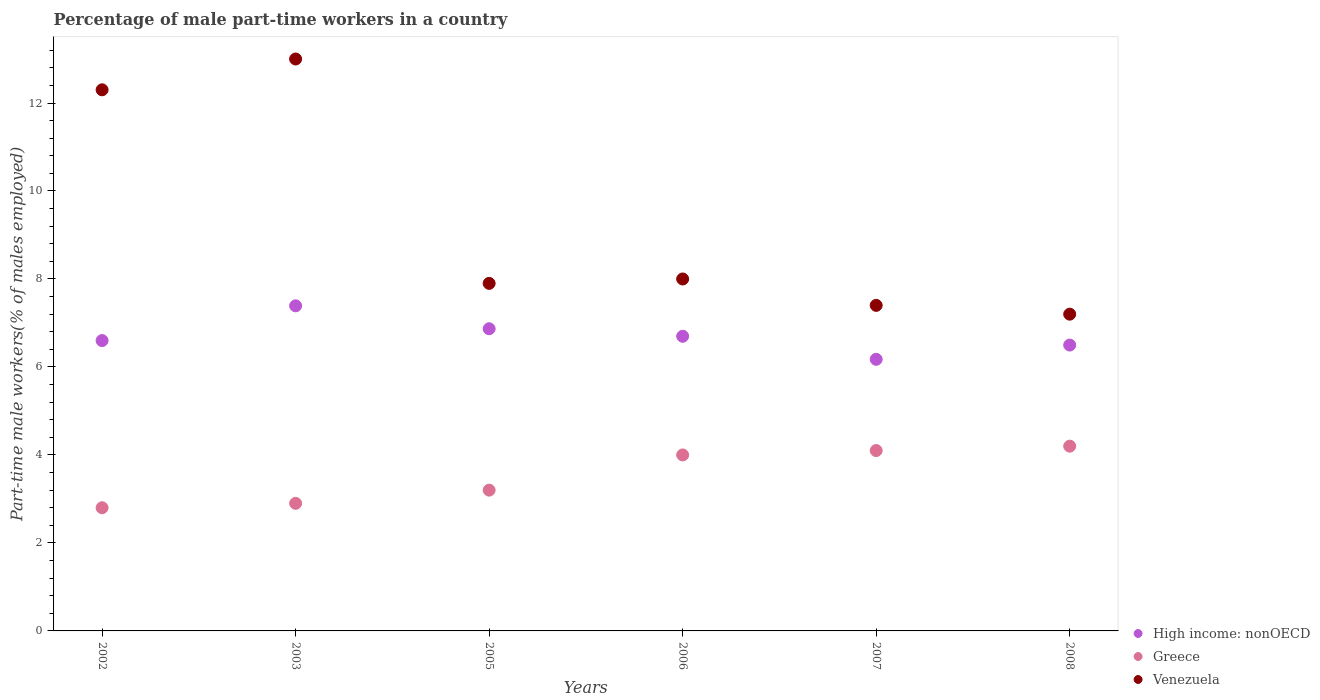How many different coloured dotlines are there?
Offer a very short reply. 3. Is the number of dotlines equal to the number of legend labels?
Provide a succinct answer. Yes. What is the percentage of male part-time workers in High income: nonOECD in 2006?
Offer a terse response. 6.7. Across all years, what is the minimum percentage of male part-time workers in Venezuela?
Offer a terse response. 7.2. In which year was the percentage of male part-time workers in Greece maximum?
Offer a very short reply. 2008. In which year was the percentage of male part-time workers in Venezuela minimum?
Give a very brief answer. 2008. What is the total percentage of male part-time workers in High income: nonOECD in the graph?
Your response must be concise. 40.23. What is the difference between the percentage of male part-time workers in Greece in 2003 and that in 2007?
Your answer should be compact. -1.2. What is the difference between the percentage of male part-time workers in Venezuela in 2002 and the percentage of male part-time workers in High income: nonOECD in 2003?
Provide a succinct answer. 4.91. What is the average percentage of male part-time workers in Venezuela per year?
Ensure brevity in your answer.  9.3. In the year 2002, what is the difference between the percentage of male part-time workers in Greece and percentage of male part-time workers in High income: nonOECD?
Keep it short and to the point. -3.8. In how many years, is the percentage of male part-time workers in High income: nonOECD greater than 4.8 %?
Offer a very short reply. 6. What is the ratio of the percentage of male part-time workers in High income: nonOECD in 2002 to that in 2008?
Provide a short and direct response. 1.02. Is the percentage of male part-time workers in High income: nonOECD in 2003 less than that in 2005?
Offer a terse response. No. What is the difference between the highest and the second highest percentage of male part-time workers in Greece?
Offer a terse response. 0.1. What is the difference between the highest and the lowest percentage of male part-time workers in High income: nonOECD?
Provide a succinct answer. 1.22. In how many years, is the percentage of male part-time workers in High income: nonOECD greater than the average percentage of male part-time workers in High income: nonOECD taken over all years?
Provide a short and direct response. 2. Is it the case that in every year, the sum of the percentage of male part-time workers in Greece and percentage of male part-time workers in High income: nonOECD  is greater than the percentage of male part-time workers in Venezuela?
Offer a terse response. No. Is the percentage of male part-time workers in High income: nonOECD strictly greater than the percentage of male part-time workers in Greece over the years?
Your answer should be very brief. Yes. Is the percentage of male part-time workers in High income: nonOECD strictly less than the percentage of male part-time workers in Greece over the years?
Provide a succinct answer. No. How many dotlines are there?
Ensure brevity in your answer.  3. How many years are there in the graph?
Your answer should be very brief. 6. Are the values on the major ticks of Y-axis written in scientific E-notation?
Provide a short and direct response. No. How many legend labels are there?
Keep it short and to the point. 3. What is the title of the graph?
Your answer should be very brief. Percentage of male part-time workers in a country. What is the label or title of the X-axis?
Offer a very short reply. Years. What is the label or title of the Y-axis?
Offer a terse response. Part-time male workers(% of males employed). What is the Part-time male workers(% of males employed) of High income: nonOECD in 2002?
Offer a terse response. 6.6. What is the Part-time male workers(% of males employed) in Greece in 2002?
Keep it short and to the point. 2.8. What is the Part-time male workers(% of males employed) in Venezuela in 2002?
Your response must be concise. 12.3. What is the Part-time male workers(% of males employed) in High income: nonOECD in 2003?
Your response must be concise. 7.39. What is the Part-time male workers(% of males employed) in Greece in 2003?
Give a very brief answer. 2.9. What is the Part-time male workers(% of males employed) in High income: nonOECD in 2005?
Your answer should be very brief. 6.87. What is the Part-time male workers(% of males employed) in Greece in 2005?
Give a very brief answer. 3.2. What is the Part-time male workers(% of males employed) in Venezuela in 2005?
Make the answer very short. 7.9. What is the Part-time male workers(% of males employed) of High income: nonOECD in 2006?
Your answer should be compact. 6.7. What is the Part-time male workers(% of males employed) in Venezuela in 2006?
Your answer should be compact. 8. What is the Part-time male workers(% of males employed) of High income: nonOECD in 2007?
Offer a terse response. 6.17. What is the Part-time male workers(% of males employed) of Greece in 2007?
Your answer should be very brief. 4.1. What is the Part-time male workers(% of males employed) of Venezuela in 2007?
Your answer should be compact. 7.4. What is the Part-time male workers(% of males employed) of High income: nonOECD in 2008?
Your answer should be very brief. 6.5. What is the Part-time male workers(% of males employed) in Greece in 2008?
Keep it short and to the point. 4.2. What is the Part-time male workers(% of males employed) of Venezuela in 2008?
Make the answer very short. 7.2. Across all years, what is the maximum Part-time male workers(% of males employed) in High income: nonOECD?
Your answer should be compact. 7.39. Across all years, what is the maximum Part-time male workers(% of males employed) in Greece?
Provide a succinct answer. 4.2. Across all years, what is the maximum Part-time male workers(% of males employed) in Venezuela?
Keep it short and to the point. 13. Across all years, what is the minimum Part-time male workers(% of males employed) of High income: nonOECD?
Keep it short and to the point. 6.17. Across all years, what is the minimum Part-time male workers(% of males employed) of Greece?
Make the answer very short. 2.8. Across all years, what is the minimum Part-time male workers(% of males employed) of Venezuela?
Your answer should be compact. 7.2. What is the total Part-time male workers(% of males employed) in High income: nonOECD in the graph?
Provide a succinct answer. 40.23. What is the total Part-time male workers(% of males employed) in Greece in the graph?
Offer a terse response. 21.2. What is the total Part-time male workers(% of males employed) in Venezuela in the graph?
Ensure brevity in your answer.  55.8. What is the difference between the Part-time male workers(% of males employed) of High income: nonOECD in 2002 and that in 2003?
Provide a succinct answer. -0.79. What is the difference between the Part-time male workers(% of males employed) of Venezuela in 2002 and that in 2003?
Make the answer very short. -0.7. What is the difference between the Part-time male workers(% of males employed) of High income: nonOECD in 2002 and that in 2005?
Ensure brevity in your answer.  -0.27. What is the difference between the Part-time male workers(% of males employed) of Greece in 2002 and that in 2005?
Provide a succinct answer. -0.4. What is the difference between the Part-time male workers(% of males employed) of Venezuela in 2002 and that in 2005?
Give a very brief answer. 4.4. What is the difference between the Part-time male workers(% of males employed) in High income: nonOECD in 2002 and that in 2006?
Your response must be concise. -0.1. What is the difference between the Part-time male workers(% of males employed) of Venezuela in 2002 and that in 2006?
Your response must be concise. 4.3. What is the difference between the Part-time male workers(% of males employed) of High income: nonOECD in 2002 and that in 2007?
Ensure brevity in your answer.  0.43. What is the difference between the Part-time male workers(% of males employed) in Greece in 2002 and that in 2007?
Provide a succinct answer. -1.3. What is the difference between the Part-time male workers(% of males employed) in Venezuela in 2002 and that in 2007?
Your answer should be compact. 4.9. What is the difference between the Part-time male workers(% of males employed) in High income: nonOECD in 2002 and that in 2008?
Make the answer very short. 0.1. What is the difference between the Part-time male workers(% of males employed) of Greece in 2002 and that in 2008?
Give a very brief answer. -1.4. What is the difference between the Part-time male workers(% of males employed) in High income: nonOECD in 2003 and that in 2005?
Ensure brevity in your answer.  0.52. What is the difference between the Part-time male workers(% of males employed) in Venezuela in 2003 and that in 2005?
Your answer should be compact. 5.1. What is the difference between the Part-time male workers(% of males employed) in High income: nonOECD in 2003 and that in 2006?
Your answer should be very brief. 0.69. What is the difference between the Part-time male workers(% of males employed) in Greece in 2003 and that in 2006?
Give a very brief answer. -1.1. What is the difference between the Part-time male workers(% of males employed) in Venezuela in 2003 and that in 2006?
Your answer should be compact. 5. What is the difference between the Part-time male workers(% of males employed) of High income: nonOECD in 2003 and that in 2007?
Your answer should be compact. 1.22. What is the difference between the Part-time male workers(% of males employed) of High income: nonOECD in 2003 and that in 2008?
Your answer should be very brief. 0.89. What is the difference between the Part-time male workers(% of males employed) in Greece in 2003 and that in 2008?
Provide a succinct answer. -1.3. What is the difference between the Part-time male workers(% of males employed) of Venezuela in 2003 and that in 2008?
Provide a short and direct response. 5.8. What is the difference between the Part-time male workers(% of males employed) of High income: nonOECD in 2005 and that in 2006?
Provide a succinct answer. 0.17. What is the difference between the Part-time male workers(% of males employed) in High income: nonOECD in 2005 and that in 2007?
Offer a terse response. 0.7. What is the difference between the Part-time male workers(% of males employed) in Greece in 2005 and that in 2007?
Keep it short and to the point. -0.9. What is the difference between the Part-time male workers(% of males employed) of Venezuela in 2005 and that in 2007?
Make the answer very short. 0.5. What is the difference between the Part-time male workers(% of males employed) of High income: nonOECD in 2005 and that in 2008?
Keep it short and to the point. 0.37. What is the difference between the Part-time male workers(% of males employed) in Greece in 2005 and that in 2008?
Provide a short and direct response. -1. What is the difference between the Part-time male workers(% of males employed) in High income: nonOECD in 2006 and that in 2007?
Make the answer very short. 0.52. What is the difference between the Part-time male workers(% of males employed) of High income: nonOECD in 2006 and that in 2008?
Give a very brief answer. 0.2. What is the difference between the Part-time male workers(% of males employed) of Greece in 2006 and that in 2008?
Offer a terse response. -0.2. What is the difference between the Part-time male workers(% of males employed) in Venezuela in 2006 and that in 2008?
Provide a succinct answer. 0.8. What is the difference between the Part-time male workers(% of males employed) of High income: nonOECD in 2007 and that in 2008?
Keep it short and to the point. -0.32. What is the difference between the Part-time male workers(% of males employed) in High income: nonOECD in 2002 and the Part-time male workers(% of males employed) in Greece in 2003?
Your answer should be compact. 3.7. What is the difference between the Part-time male workers(% of males employed) in High income: nonOECD in 2002 and the Part-time male workers(% of males employed) in Venezuela in 2003?
Provide a short and direct response. -6.4. What is the difference between the Part-time male workers(% of males employed) in Greece in 2002 and the Part-time male workers(% of males employed) in Venezuela in 2003?
Your response must be concise. -10.2. What is the difference between the Part-time male workers(% of males employed) in High income: nonOECD in 2002 and the Part-time male workers(% of males employed) in Greece in 2005?
Provide a short and direct response. 3.4. What is the difference between the Part-time male workers(% of males employed) in High income: nonOECD in 2002 and the Part-time male workers(% of males employed) in Venezuela in 2005?
Provide a short and direct response. -1.3. What is the difference between the Part-time male workers(% of males employed) in High income: nonOECD in 2002 and the Part-time male workers(% of males employed) in Greece in 2006?
Ensure brevity in your answer.  2.6. What is the difference between the Part-time male workers(% of males employed) of High income: nonOECD in 2002 and the Part-time male workers(% of males employed) of Venezuela in 2006?
Offer a very short reply. -1.4. What is the difference between the Part-time male workers(% of males employed) in Greece in 2002 and the Part-time male workers(% of males employed) in Venezuela in 2006?
Offer a very short reply. -5.2. What is the difference between the Part-time male workers(% of males employed) in High income: nonOECD in 2002 and the Part-time male workers(% of males employed) in Greece in 2007?
Make the answer very short. 2.5. What is the difference between the Part-time male workers(% of males employed) of High income: nonOECD in 2002 and the Part-time male workers(% of males employed) of Venezuela in 2007?
Your answer should be very brief. -0.8. What is the difference between the Part-time male workers(% of males employed) of Greece in 2002 and the Part-time male workers(% of males employed) of Venezuela in 2007?
Provide a short and direct response. -4.6. What is the difference between the Part-time male workers(% of males employed) in High income: nonOECD in 2002 and the Part-time male workers(% of males employed) in Greece in 2008?
Provide a short and direct response. 2.4. What is the difference between the Part-time male workers(% of males employed) in High income: nonOECD in 2002 and the Part-time male workers(% of males employed) in Venezuela in 2008?
Your answer should be compact. -0.6. What is the difference between the Part-time male workers(% of males employed) of Greece in 2002 and the Part-time male workers(% of males employed) of Venezuela in 2008?
Your response must be concise. -4.4. What is the difference between the Part-time male workers(% of males employed) of High income: nonOECD in 2003 and the Part-time male workers(% of males employed) of Greece in 2005?
Offer a very short reply. 4.19. What is the difference between the Part-time male workers(% of males employed) of High income: nonOECD in 2003 and the Part-time male workers(% of males employed) of Venezuela in 2005?
Provide a succinct answer. -0.51. What is the difference between the Part-time male workers(% of males employed) in High income: nonOECD in 2003 and the Part-time male workers(% of males employed) in Greece in 2006?
Make the answer very short. 3.39. What is the difference between the Part-time male workers(% of males employed) of High income: nonOECD in 2003 and the Part-time male workers(% of males employed) of Venezuela in 2006?
Your response must be concise. -0.61. What is the difference between the Part-time male workers(% of males employed) of Greece in 2003 and the Part-time male workers(% of males employed) of Venezuela in 2006?
Provide a short and direct response. -5.1. What is the difference between the Part-time male workers(% of males employed) of High income: nonOECD in 2003 and the Part-time male workers(% of males employed) of Greece in 2007?
Give a very brief answer. 3.29. What is the difference between the Part-time male workers(% of males employed) in High income: nonOECD in 2003 and the Part-time male workers(% of males employed) in Venezuela in 2007?
Provide a succinct answer. -0.01. What is the difference between the Part-time male workers(% of males employed) in High income: nonOECD in 2003 and the Part-time male workers(% of males employed) in Greece in 2008?
Your response must be concise. 3.19. What is the difference between the Part-time male workers(% of males employed) of High income: nonOECD in 2003 and the Part-time male workers(% of males employed) of Venezuela in 2008?
Make the answer very short. 0.19. What is the difference between the Part-time male workers(% of males employed) in High income: nonOECD in 2005 and the Part-time male workers(% of males employed) in Greece in 2006?
Give a very brief answer. 2.87. What is the difference between the Part-time male workers(% of males employed) of High income: nonOECD in 2005 and the Part-time male workers(% of males employed) of Venezuela in 2006?
Your answer should be compact. -1.13. What is the difference between the Part-time male workers(% of males employed) in Greece in 2005 and the Part-time male workers(% of males employed) in Venezuela in 2006?
Keep it short and to the point. -4.8. What is the difference between the Part-time male workers(% of males employed) in High income: nonOECD in 2005 and the Part-time male workers(% of males employed) in Greece in 2007?
Offer a very short reply. 2.77. What is the difference between the Part-time male workers(% of males employed) in High income: nonOECD in 2005 and the Part-time male workers(% of males employed) in Venezuela in 2007?
Provide a short and direct response. -0.53. What is the difference between the Part-time male workers(% of males employed) in Greece in 2005 and the Part-time male workers(% of males employed) in Venezuela in 2007?
Your answer should be very brief. -4.2. What is the difference between the Part-time male workers(% of males employed) of High income: nonOECD in 2005 and the Part-time male workers(% of males employed) of Greece in 2008?
Your response must be concise. 2.67. What is the difference between the Part-time male workers(% of males employed) of High income: nonOECD in 2005 and the Part-time male workers(% of males employed) of Venezuela in 2008?
Make the answer very short. -0.33. What is the difference between the Part-time male workers(% of males employed) in Greece in 2005 and the Part-time male workers(% of males employed) in Venezuela in 2008?
Your answer should be compact. -4. What is the difference between the Part-time male workers(% of males employed) of High income: nonOECD in 2006 and the Part-time male workers(% of males employed) of Greece in 2007?
Provide a succinct answer. 2.6. What is the difference between the Part-time male workers(% of males employed) of High income: nonOECD in 2006 and the Part-time male workers(% of males employed) of Venezuela in 2007?
Make the answer very short. -0.7. What is the difference between the Part-time male workers(% of males employed) of High income: nonOECD in 2006 and the Part-time male workers(% of males employed) of Greece in 2008?
Offer a very short reply. 2.5. What is the difference between the Part-time male workers(% of males employed) in High income: nonOECD in 2006 and the Part-time male workers(% of males employed) in Venezuela in 2008?
Your answer should be very brief. -0.5. What is the difference between the Part-time male workers(% of males employed) of High income: nonOECD in 2007 and the Part-time male workers(% of males employed) of Greece in 2008?
Offer a very short reply. 1.97. What is the difference between the Part-time male workers(% of males employed) in High income: nonOECD in 2007 and the Part-time male workers(% of males employed) in Venezuela in 2008?
Your answer should be very brief. -1.03. What is the average Part-time male workers(% of males employed) in High income: nonOECD per year?
Provide a succinct answer. 6.7. What is the average Part-time male workers(% of males employed) in Greece per year?
Your answer should be compact. 3.53. In the year 2002, what is the difference between the Part-time male workers(% of males employed) in High income: nonOECD and Part-time male workers(% of males employed) in Greece?
Your answer should be very brief. 3.8. In the year 2002, what is the difference between the Part-time male workers(% of males employed) in High income: nonOECD and Part-time male workers(% of males employed) in Venezuela?
Offer a terse response. -5.7. In the year 2002, what is the difference between the Part-time male workers(% of males employed) in Greece and Part-time male workers(% of males employed) in Venezuela?
Give a very brief answer. -9.5. In the year 2003, what is the difference between the Part-time male workers(% of males employed) of High income: nonOECD and Part-time male workers(% of males employed) of Greece?
Offer a very short reply. 4.49. In the year 2003, what is the difference between the Part-time male workers(% of males employed) in High income: nonOECD and Part-time male workers(% of males employed) in Venezuela?
Provide a short and direct response. -5.61. In the year 2005, what is the difference between the Part-time male workers(% of males employed) of High income: nonOECD and Part-time male workers(% of males employed) of Greece?
Provide a short and direct response. 3.67. In the year 2005, what is the difference between the Part-time male workers(% of males employed) of High income: nonOECD and Part-time male workers(% of males employed) of Venezuela?
Your answer should be compact. -1.03. In the year 2005, what is the difference between the Part-time male workers(% of males employed) in Greece and Part-time male workers(% of males employed) in Venezuela?
Offer a very short reply. -4.7. In the year 2006, what is the difference between the Part-time male workers(% of males employed) in High income: nonOECD and Part-time male workers(% of males employed) in Greece?
Offer a terse response. 2.7. In the year 2006, what is the difference between the Part-time male workers(% of males employed) in High income: nonOECD and Part-time male workers(% of males employed) in Venezuela?
Offer a terse response. -1.3. In the year 2007, what is the difference between the Part-time male workers(% of males employed) in High income: nonOECD and Part-time male workers(% of males employed) in Greece?
Provide a short and direct response. 2.07. In the year 2007, what is the difference between the Part-time male workers(% of males employed) in High income: nonOECD and Part-time male workers(% of males employed) in Venezuela?
Ensure brevity in your answer.  -1.23. In the year 2007, what is the difference between the Part-time male workers(% of males employed) in Greece and Part-time male workers(% of males employed) in Venezuela?
Your answer should be compact. -3.3. In the year 2008, what is the difference between the Part-time male workers(% of males employed) of High income: nonOECD and Part-time male workers(% of males employed) of Greece?
Your response must be concise. 2.3. In the year 2008, what is the difference between the Part-time male workers(% of males employed) of High income: nonOECD and Part-time male workers(% of males employed) of Venezuela?
Offer a very short reply. -0.7. In the year 2008, what is the difference between the Part-time male workers(% of males employed) in Greece and Part-time male workers(% of males employed) in Venezuela?
Offer a terse response. -3. What is the ratio of the Part-time male workers(% of males employed) in High income: nonOECD in 2002 to that in 2003?
Your answer should be compact. 0.89. What is the ratio of the Part-time male workers(% of males employed) of Greece in 2002 to that in 2003?
Offer a terse response. 0.97. What is the ratio of the Part-time male workers(% of males employed) in Venezuela in 2002 to that in 2003?
Keep it short and to the point. 0.95. What is the ratio of the Part-time male workers(% of males employed) of High income: nonOECD in 2002 to that in 2005?
Ensure brevity in your answer.  0.96. What is the ratio of the Part-time male workers(% of males employed) in Venezuela in 2002 to that in 2005?
Provide a short and direct response. 1.56. What is the ratio of the Part-time male workers(% of males employed) of High income: nonOECD in 2002 to that in 2006?
Offer a terse response. 0.99. What is the ratio of the Part-time male workers(% of males employed) in Venezuela in 2002 to that in 2006?
Make the answer very short. 1.54. What is the ratio of the Part-time male workers(% of males employed) of High income: nonOECD in 2002 to that in 2007?
Make the answer very short. 1.07. What is the ratio of the Part-time male workers(% of males employed) in Greece in 2002 to that in 2007?
Offer a terse response. 0.68. What is the ratio of the Part-time male workers(% of males employed) of Venezuela in 2002 to that in 2007?
Give a very brief answer. 1.66. What is the ratio of the Part-time male workers(% of males employed) in High income: nonOECD in 2002 to that in 2008?
Provide a short and direct response. 1.02. What is the ratio of the Part-time male workers(% of males employed) in Greece in 2002 to that in 2008?
Make the answer very short. 0.67. What is the ratio of the Part-time male workers(% of males employed) in Venezuela in 2002 to that in 2008?
Offer a very short reply. 1.71. What is the ratio of the Part-time male workers(% of males employed) of High income: nonOECD in 2003 to that in 2005?
Make the answer very short. 1.08. What is the ratio of the Part-time male workers(% of males employed) of Greece in 2003 to that in 2005?
Give a very brief answer. 0.91. What is the ratio of the Part-time male workers(% of males employed) of Venezuela in 2003 to that in 2005?
Keep it short and to the point. 1.65. What is the ratio of the Part-time male workers(% of males employed) of High income: nonOECD in 2003 to that in 2006?
Your answer should be compact. 1.1. What is the ratio of the Part-time male workers(% of males employed) of Greece in 2003 to that in 2006?
Give a very brief answer. 0.72. What is the ratio of the Part-time male workers(% of males employed) in Venezuela in 2003 to that in 2006?
Offer a very short reply. 1.62. What is the ratio of the Part-time male workers(% of males employed) of High income: nonOECD in 2003 to that in 2007?
Ensure brevity in your answer.  1.2. What is the ratio of the Part-time male workers(% of males employed) in Greece in 2003 to that in 2007?
Make the answer very short. 0.71. What is the ratio of the Part-time male workers(% of males employed) in Venezuela in 2003 to that in 2007?
Your answer should be compact. 1.76. What is the ratio of the Part-time male workers(% of males employed) of High income: nonOECD in 2003 to that in 2008?
Ensure brevity in your answer.  1.14. What is the ratio of the Part-time male workers(% of males employed) in Greece in 2003 to that in 2008?
Offer a very short reply. 0.69. What is the ratio of the Part-time male workers(% of males employed) in Venezuela in 2003 to that in 2008?
Provide a short and direct response. 1.81. What is the ratio of the Part-time male workers(% of males employed) in High income: nonOECD in 2005 to that in 2006?
Give a very brief answer. 1.03. What is the ratio of the Part-time male workers(% of males employed) in Venezuela in 2005 to that in 2006?
Your answer should be compact. 0.99. What is the ratio of the Part-time male workers(% of males employed) in High income: nonOECD in 2005 to that in 2007?
Provide a short and direct response. 1.11. What is the ratio of the Part-time male workers(% of males employed) in Greece in 2005 to that in 2007?
Provide a succinct answer. 0.78. What is the ratio of the Part-time male workers(% of males employed) of Venezuela in 2005 to that in 2007?
Keep it short and to the point. 1.07. What is the ratio of the Part-time male workers(% of males employed) in High income: nonOECD in 2005 to that in 2008?
Offer a very short reply. 1.06. What is the ratio of the Part-time male workers(% of males employed) of Greece in 2005 to that in 2008?
Your answer should be compact. 0.76. What is the ratio of the Part-time male workers(% of males employed) of Venezuela in 2005 to that in 2008?
Give a very brief answer. 1.1. What is the ratio of the Part-time male workers(% of males employed) in High income: nonOECD in 2006 to that in 2007?
Offer a terse response. 1.08. What is the ratio of the Part-time male workers(% of males employed) in Greece in 2006 to that in 2007?
Make the answer very short. 0.98. What is the ratio of the Part-time male workers(% of males employed) in Venezuela in 2006 to that in 2007?
Provide a succinct answer. 1.08. What is the ratio of the Part-time male workers(% of males employed) of High income: nonOECD in 2006 to that in 2008?
Offer a terse response. 1.03. What is the ratio of the Part-time male workers(% of males employed) in High income: nonOECD in 2007 to that in 2008?
Your answer should be compact. 0.95. What is the ratio of the Part-time male workers(% of males employed) in Greece in 2007 to that in 2008?
Ensure brevity in your answer.  0.98. What is the ratio of the Part-time male workers(% of males employed) in Venezuela in 2007 to that in 2008?
Ensure brevity in your answer.  1.03. What is the difference between the highest and the second highest Part-time male workers(% of males employed) of High income: nonOECD?
Ensure brevity in your answer.  0.52. What is the difference between the highest and the lowest Part-time male workers(% of males employed) of High income: nonOECD?
Offer a very short reply. 1.22. What is the difference between the highest and the lowest Part-time male workers(% of males employed) in Greece?
Give a very brief answer. 1.4. What is the difference between the highest and the lowest Part-time male workers(% of males employed) in Venezuela?
Make the answer very short. 5.8. 